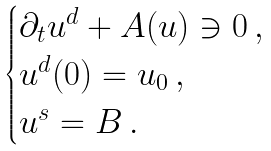Convert formula to latex. <formula><loc_0><loc_0><loc_500><loc_500>\begin{cases} \partial _ { t } u ^ { d } + A ( u ) \ni 0 \, , \\ u ^ { d } ( 0 ) = u _ { 0 } \, , \\ u ^ { s } = B \, . \end{cases}</formula> 